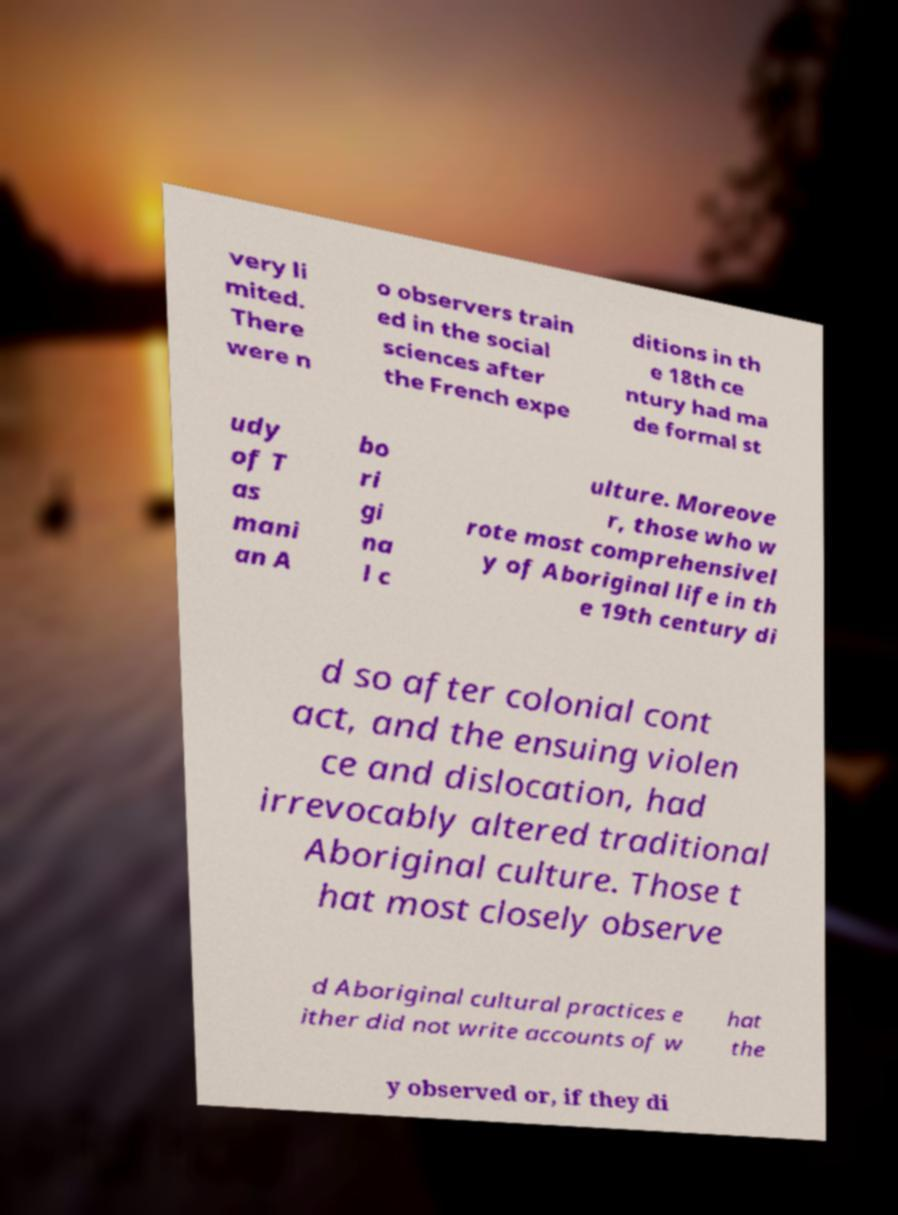Could you assist in decoding the text presented in this image and type it out clearly? very li mited. There were n o observers train ed in the social sciences after the French expe ditions in th e 18th ce ntury had ma de formal st udy of T as mani an A bo ri gi na l c ulture. Moreove r, those who w rote most comprehensivel y of Aboriginal life in th e 19th century di d so after colonial cont act, and the ensuing violen ce and dislocation, had irrevocably altered traditional Aboriginal culture. Those t hat most closely observe d Aboriginal cultural practices e ither did not write accounts of w hat the y observed or, if they di 